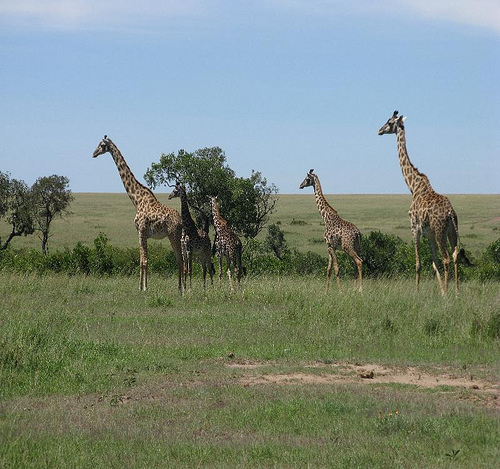<image>What are the smaller animals to the left? I am not sure about the smaller animals to the left. It could be a giraffe, baby giraffe, ants, or birds. What are the smaller animals to the left? I don't know what the smaller animals to the left are. It can be giraffes, baby giraffes, ants, or birds. 